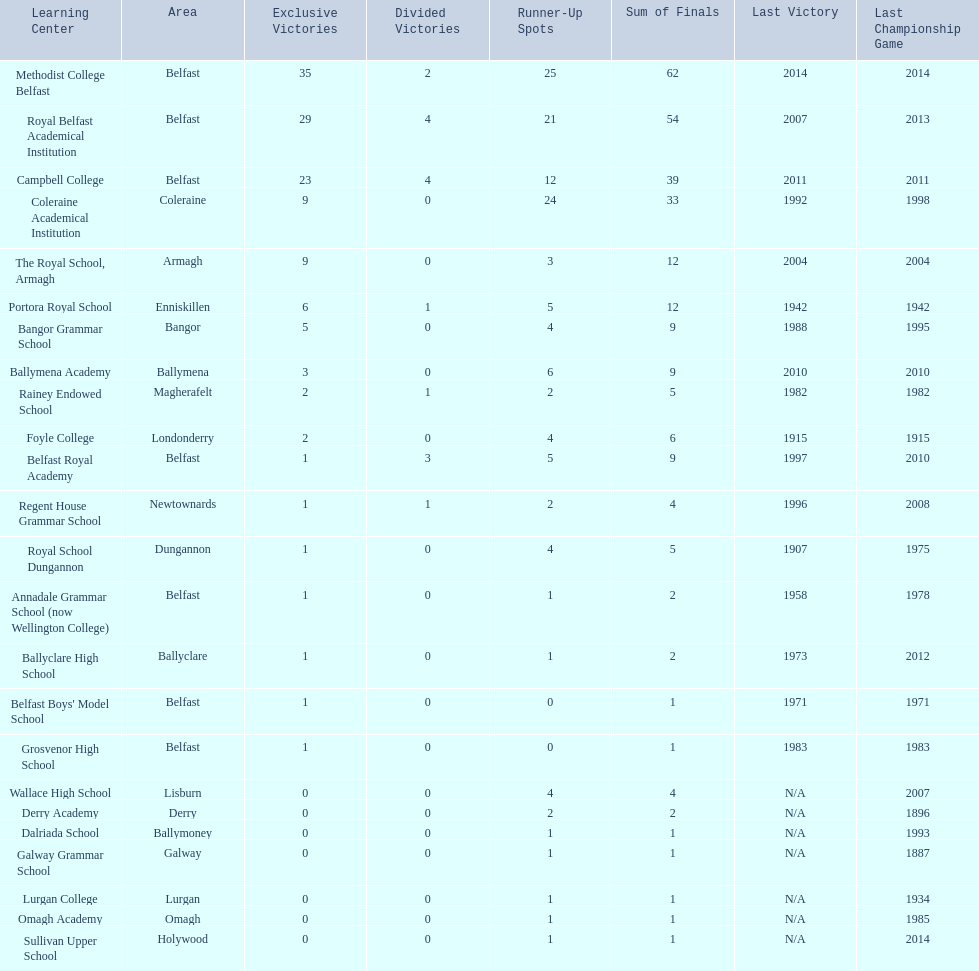What is the difference in runners-up from coleraine academical institution and royal school dungannon? 20. 